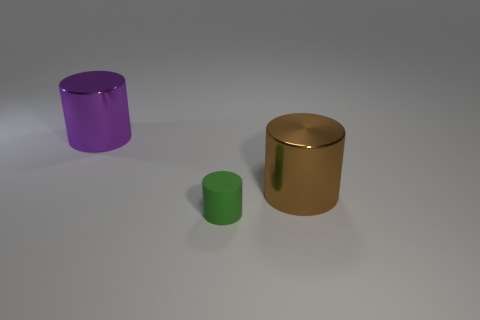What shape is the large metallic thing that is behind the large object that is in front of the cylinder behind the large brown cylinder?
Ensure brevity in your answer.  Cylinder. There is a large brown object that is the same shape as the green rubber thing; what material is it?
Provide a short and direct response. Metal. Are there any other things that are the same size as the purple metallic thing?
Provide a succinct answer. Yes. Do the big shiny object on the left side of the large brown metallic thing and the thing that is right of the small matte cylinder have the same shape?
Provide a succinct answer. Yes. Is the number of green cylinders that are in front of the green matte thing less than the number of cylinders that are behind the big purple cylinder?
Ensure brevity in your answer.  No. What number of other things are the same shape as the big purple metallic thing?
Offer a terse response. 2. There is a object that is the same material as the purple cylinder; what is its shape?
Ensure brevity in your answer.  Cylinder. What color is the object that is both behind the rubber cylinder and left of the big brown cylinder?
Provide a short and direct response. Purple. Do the big cylinder on the left side of the large brown cylinder and the small thing have the same material?
Offer a very short reply. No. Is the number of tiny rubber objects on the right side of the large brown metal cylinder less than the number of big cylinders?
Keep it short and to the point. Yes. 